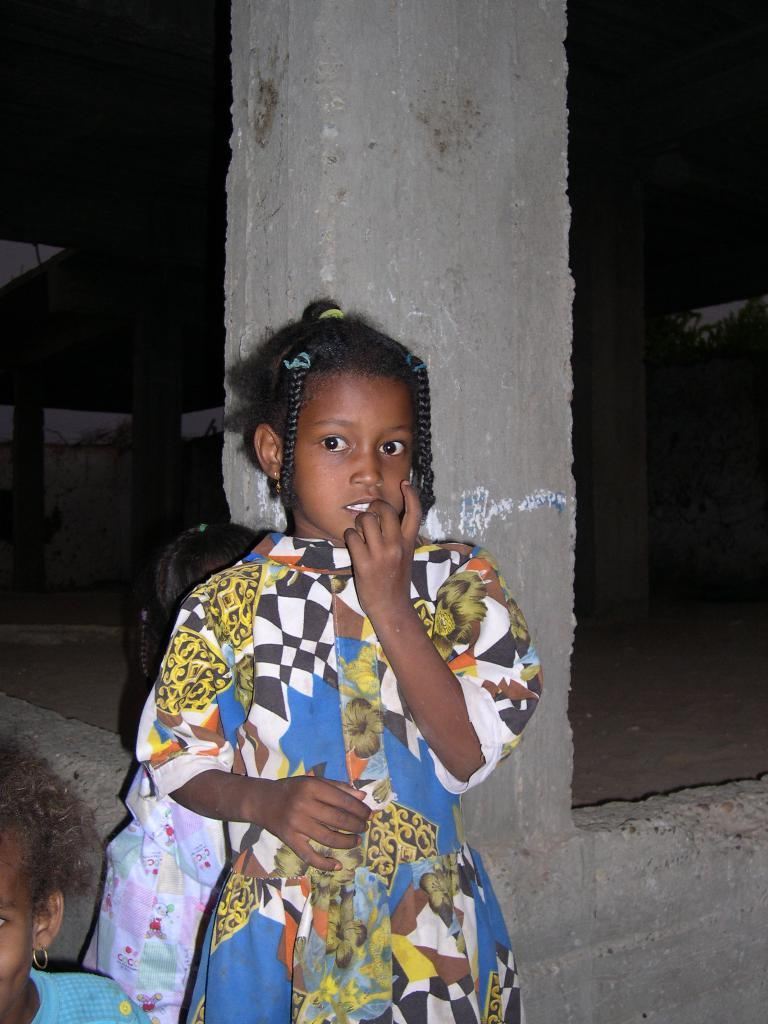How many children are present in the image? There are three kids in the image. What can be seen in the background of the image? There is a building under construction in the background. What is the color of the background in the image? The background of the image is dark. What type of profit can be seen in the image? There is no mention of profit in the image; it features three kids and a building under construction in the background. Can you tell me how many frogs are present in the image? There are no frogs present in the image. 